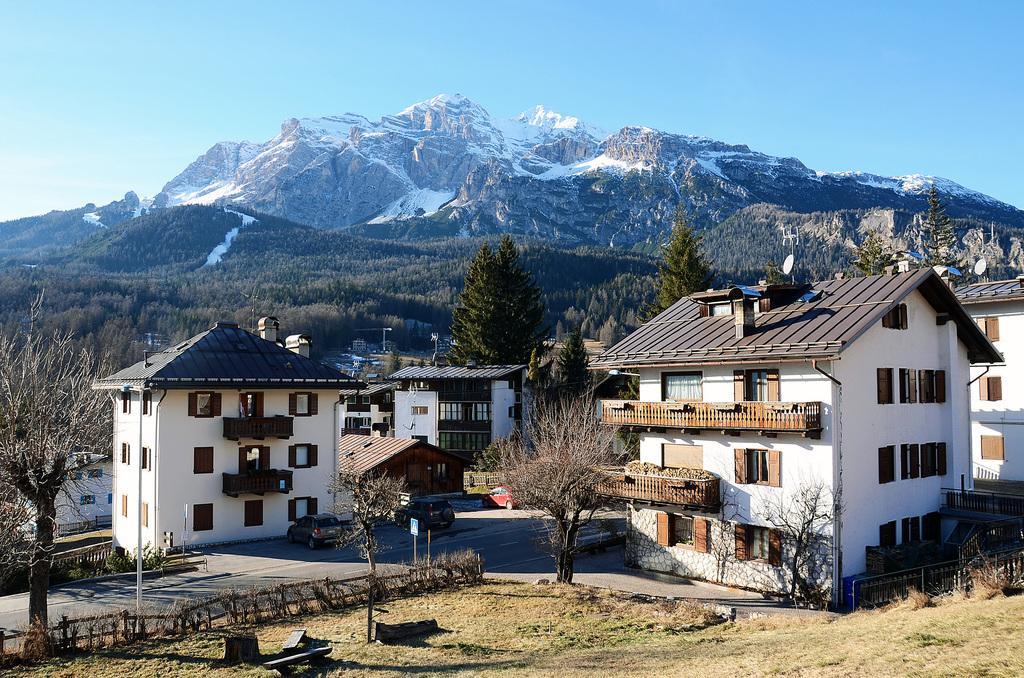In one or two sentences, can you explain what this image depicts? In this picture I can observe buildings and trees. In the background there are mountains and sky. 